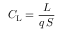<formula> <loc_0><loc_0><loc_500><loc_500>C _ { L } = { \frac { L } { q \, S } }</formula> 